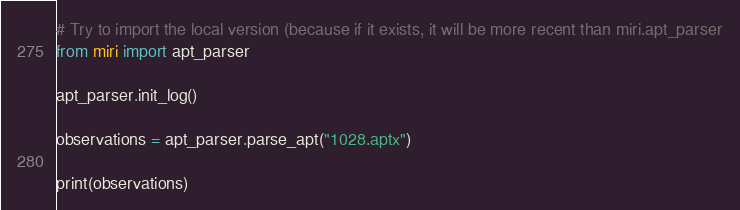Convert code to text. <code><loc_0><loc_0><loc_500><loc_500><_Python_>
# Try to import the local version (because if it exists, it will be more recent than miri.apt_parser
from miri import apt_parser

apt_parser.init_log()

observations = apt_parser.parse_apt("1028.aptx")

print(observations)
</code> 